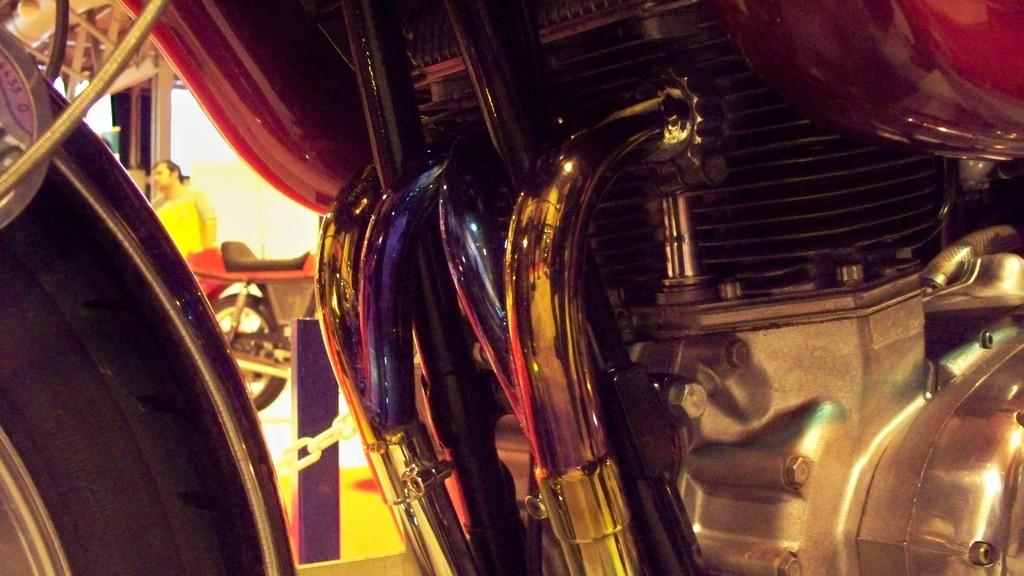What is the main subject of the image? The main subject of the image is an engine of a motorbike. What can be seen on the left side of the image? There is a tyre on the left side of the image. Can you describe the man's location in the image? The man is standing in the background of the image and is near the motorbike. What type of slope can be seen in the image? There is no slope present in the image. Is the man sleeping in the image? The man is standing in the image, not sleeping. 